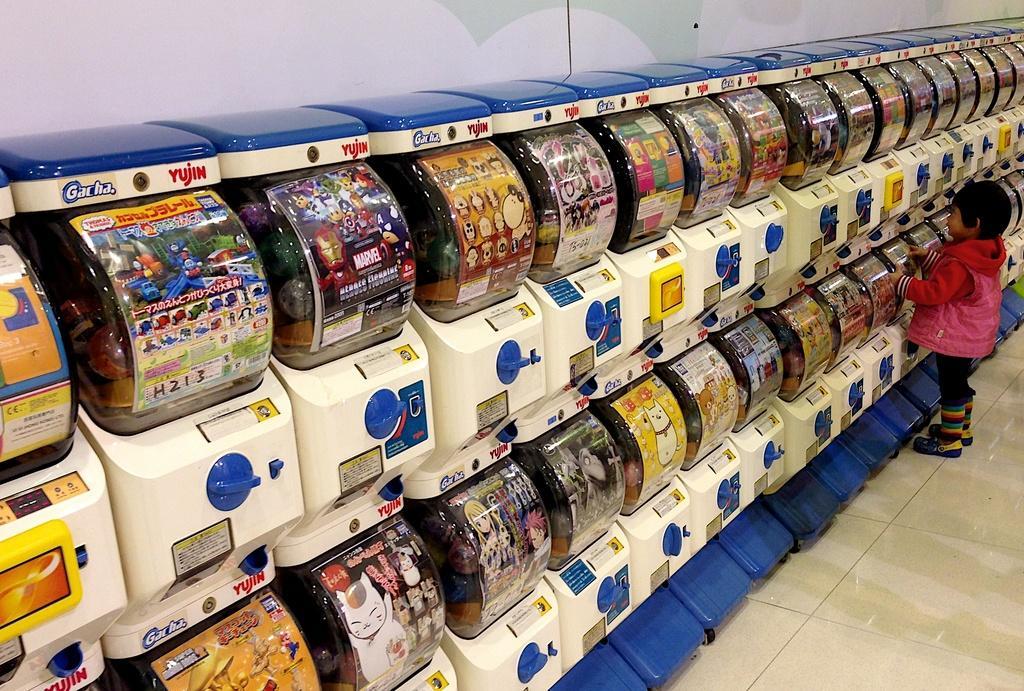In one or two sentences, can you explain what this image depicts? There are different types of toy machines and a kid is standing in front of one of the machine,he is wearing pink jacket. 